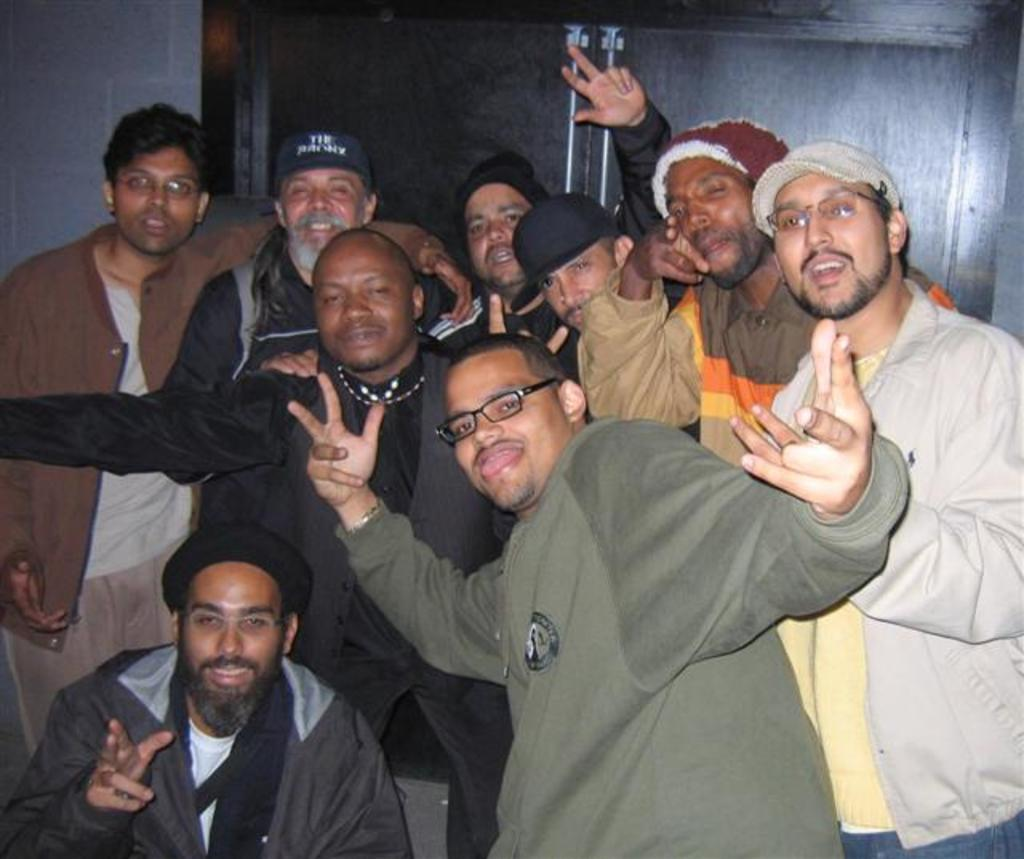How many people are in the image? There are multiple people in the image. What type of clothing are most of the people wearing? Most of the people are wearing jackets. Are there any accessories visible on the people in the image? Yes, some people are wearing caps. Can you describe the appearance of one person in the front? One person in the front is wearing glasses (specs). What type of act are the mice performing in the image? There are no mice present in the image, so it is not possible to answer that question. 